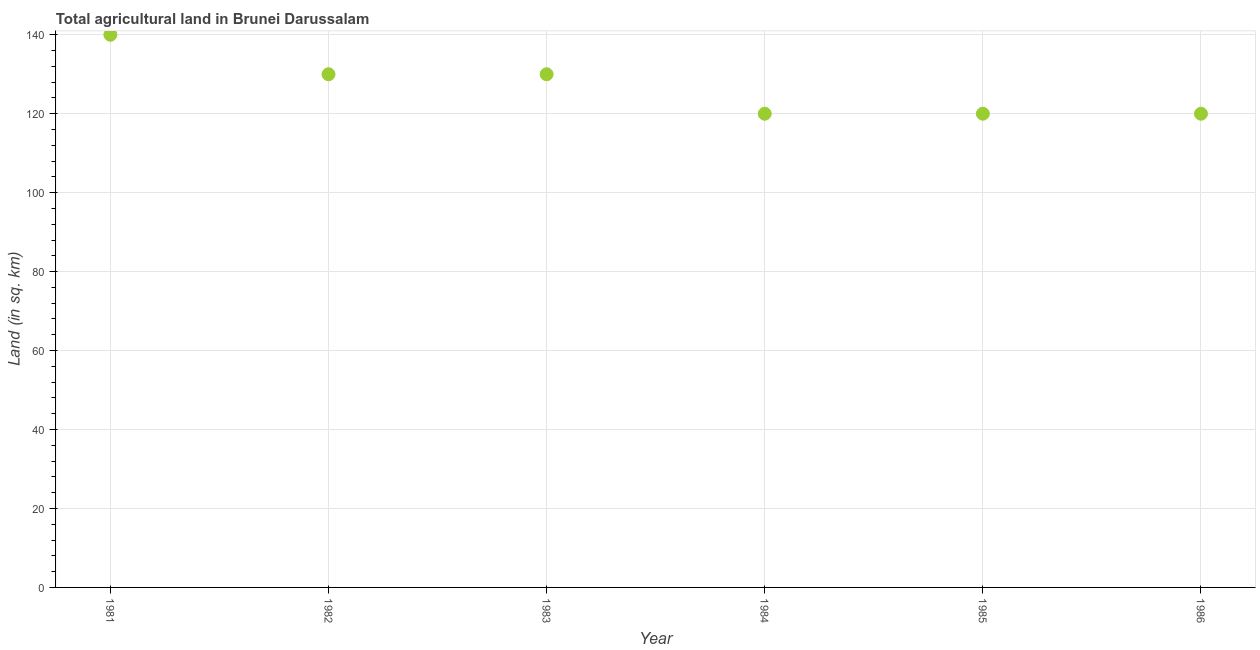What is the agricultural land in 1982?
Give a very brief answer. 130. Across all years, what is the maximum agricultural land?
Provide a short and direct response. 140. Across all years, what is the minimum agricultural land?
Provide a succinct answer. 120. What is the sum of the agricultural land?
Give a very brief answer. 760. What is the difference between the agricultural land in 1982 and 1985?
Make the answer very short. 10. What is the average agricultural land per year?
Provide a short and direct response. 126.67. What is the median agricultural land?
Provide a short and direct response. 125. In how many years, is the agricultural land greater than 72 sq. km?
Offer a very short reply. 6. Do a majority of the years between 1981 and 1983 (inclusive) have agricultural land greater than 68 sq. km?
Provide a succinct answer. Yes. Is the agricultural land in 1985 less than that in 1986?
Offer a very short reply. No. What is the difference between the highest and the second highest agricultural land?
Keep it short and to the point. 10. What is the difference between the highest and the lowest agricultural land?
Keep it short and to the point. 20. What is the difference between two consecutive major ticks on the Y-axis?
Keep it short and to the point. 20. What is the title of the graph?
Your answer should be very brief. Total agricultural land in Brunei Darussalam. What is the label or title of the Y-axis?
Offer a terse response. Land (in sq. km). What is the Land (in sq. km) in 1981?
Your response must be concise. 140. What is the Land (in sq. km) in 1982?
Make the answer very short. 130. What is the Land (in sq. km) in 1983?
Your response must be concise. 130. What is the Land (in sq. km) in 1984?
Provide a short and direct response. 120. What is the Land (in sq. km) in 1985?
Your response must be concise. 120. What is the Land (in sq. km) in 1986?
Your response must be concise. 120. What is the difference between the Land (in sq. km) in 1981 and 1983?
Provide a short and direct response. 10. What is the difference between the Land (in sq. km) in 1981 and 1984?
Your response must be concise. 20. What is the difference between the Land (in sq. km) in 1981 and 1986?
Ensure brevity in your answer.  20. What is the difference between the Land (in sq. km) in 1982 and 1984?
Offer a very short reply. 10. What is the difference between the Land (in sq. km) in 1982 and 1986?
Give a very brief answer. 10. What is the difference between the Land (in sq. km) in 1984 and 1986?
Your response must be concise. 0. What is the difference between the Land (in sq. km) in 1985 and 1986?
Provide a succinct answer. 0. What is the ratio of the Land (in sq. km) in 1981 to that in 1982?
Your answer should be very brief. 1.08. What is the ratio of the Land (in sq. km) in 1981 to that in 1983?
Provide a succinct answer. 1.08. What is the ratio of the Land (in sq. km) in 1981 to that in 1984?
Keep it short and to the point. 1.17. What is the ratio of the Land (in sq. km) in 1981 to that in 1985?
Your answer should be very brief. 1.17. What is the ratio of the Land (in sq. km) in 1981 to that in 1986?
Your answer should be very brief. 1.17. What is the ratio of the Land (in sq. km) in 1982 to that in 1983?
Provide a succinct answer. 1. What is the ratio of the Land (in sq. km) in 1982 to that in 1984?
Give a very brief answer. 1.08. What is the ratio of the Land (in sq. km) in 1982 to that in 1985?
Give a very brief answer. 1.08. What is the ratio of the Land (in sq. km) in 1982 to that in 1986?
Offer a terse response. 1.08. What is the ratio of the Land (in sq. km) in 1983 to that in 1984?
Provide a short and direct response. 1.08. What is the ratio of the Land (in sq. km) in 1983 to that in 1985?
Give a very brief answer. 1.08. What is the ratio of the Land (in sq. km) in 1983 to that in 1986?
Offer a terse response. 1.08. What is the ratio of the Land (in sq. km) in 1984 to that in 1985?
Offer a terse response. 1. What is the ratio of the Land (in sq. km) in 1984 to that in 1986?
Ensure brevity in your answer.  1. 